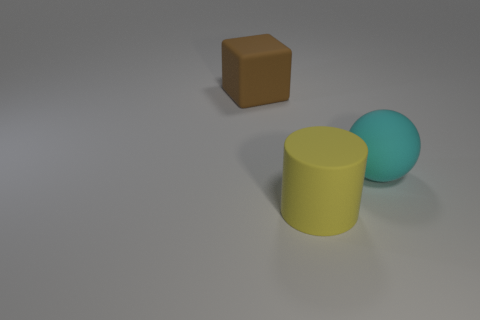Is there any other thing that is the same shape as the yellow thing?
Offer a terse response. No. There is a object that is behind the matte object on the right side of the matte object that is in front of the large cyan rubber thing; what is its size?
Your answer should be very brief. Large. Is the number of large objects left of the sphere greater than the number of big rubber cylinders that are on the right side of the cylinder?
Ensure brevity in your answer.  Yes. What number of blocks are left of the big thing in front of the big matte ball?
Ensure brevity in your answer.  1. Is the size of the block the same as the cyan rubber ball?
Provide a succinct answer. Yes. The big object in front of the large rubber thing that is right of the large yellow cylinder is made of what material?
Offer a terse response. Rubber. How many rubber things are brown things or big cyan spheres?
Your response must be concise. 2. Are the cylinder and the sphere made of the same material?
Provide a short and direct response. Yes. There is a large brown rubber thing; what shape is it?
Provide a short and direct response. Cube. What number of objects are yellow cylinders or matte objects that are in front of the big brown matte thing?
Make the answer very short. 2. 